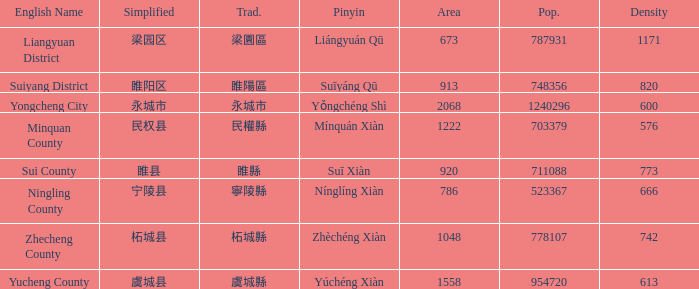What is the traditional form for 宁陵县? 寧陵縣. 